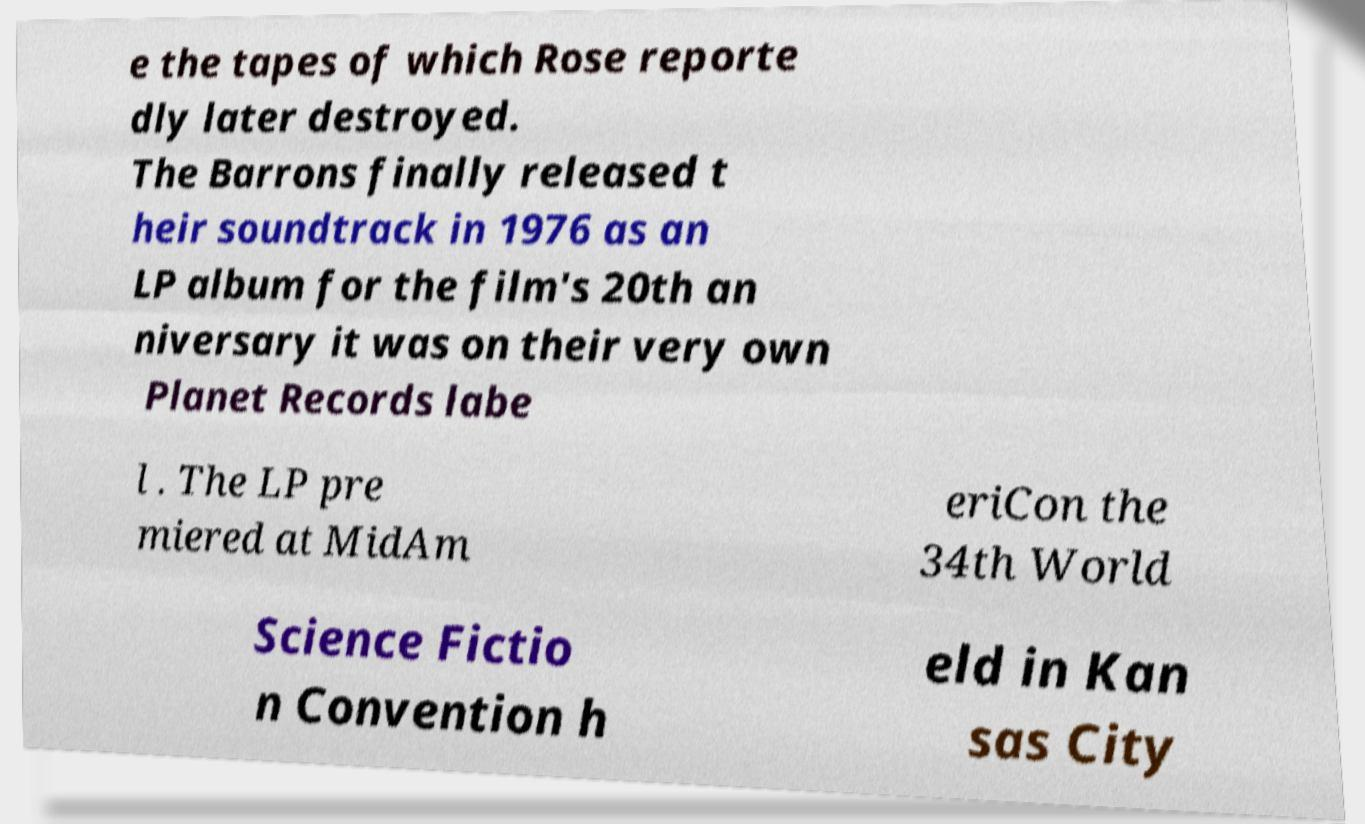For documentation purposes, I need the text within this image transcribed. Could you provide that? e the tapes of which Rose reporte dly later destroyed. The Barrons finally released t heir soundtrack in 1976 as an LP album for the film's 20th an niversary it was on their very own Planet Records labe l . The LP pre miered at MidAm eriCon the 34th World Science Fictio n Convention h eld in Kan sas City 